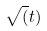<formula> <loc_0><loc_0><loc_500><loc_500>\sqrt { ( } t )</formula> 